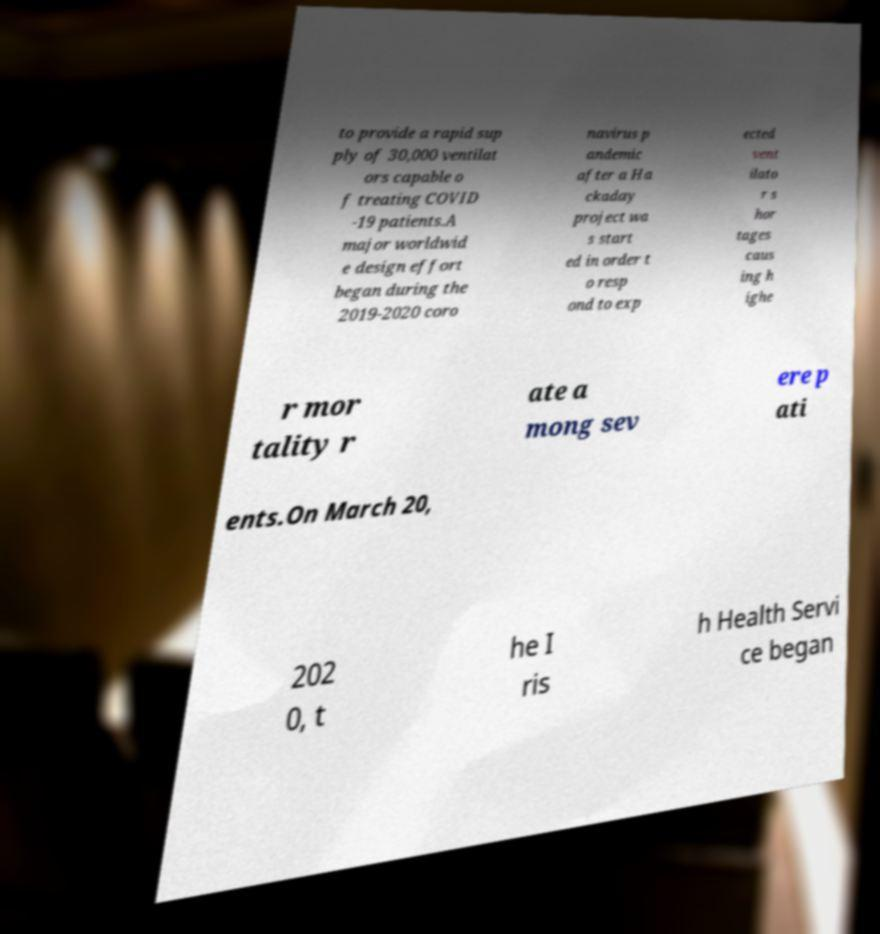There's text embedded in this image that I need extracted. Can you transcribe it verbatim? to provide a rapid sup ply of 30,000 ventilat ors capable o f treating COVID -19 patients.A major worldwid e design effort began during the 2019-2020 coro navirus p andemic after a Ha ckaday project wa s start ed in order t o resp ond to exp ected vent ilato r s hor tages caus ing h ighe r mor tality r ate a mong sev ere p ati ents.On March 20, 202 0, t he I ris h Health Servi ce began 